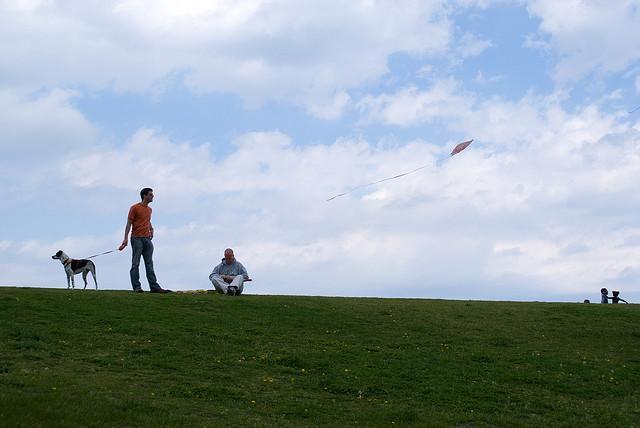How many dogs are in the picture?
Give a very brief answer. 1. 